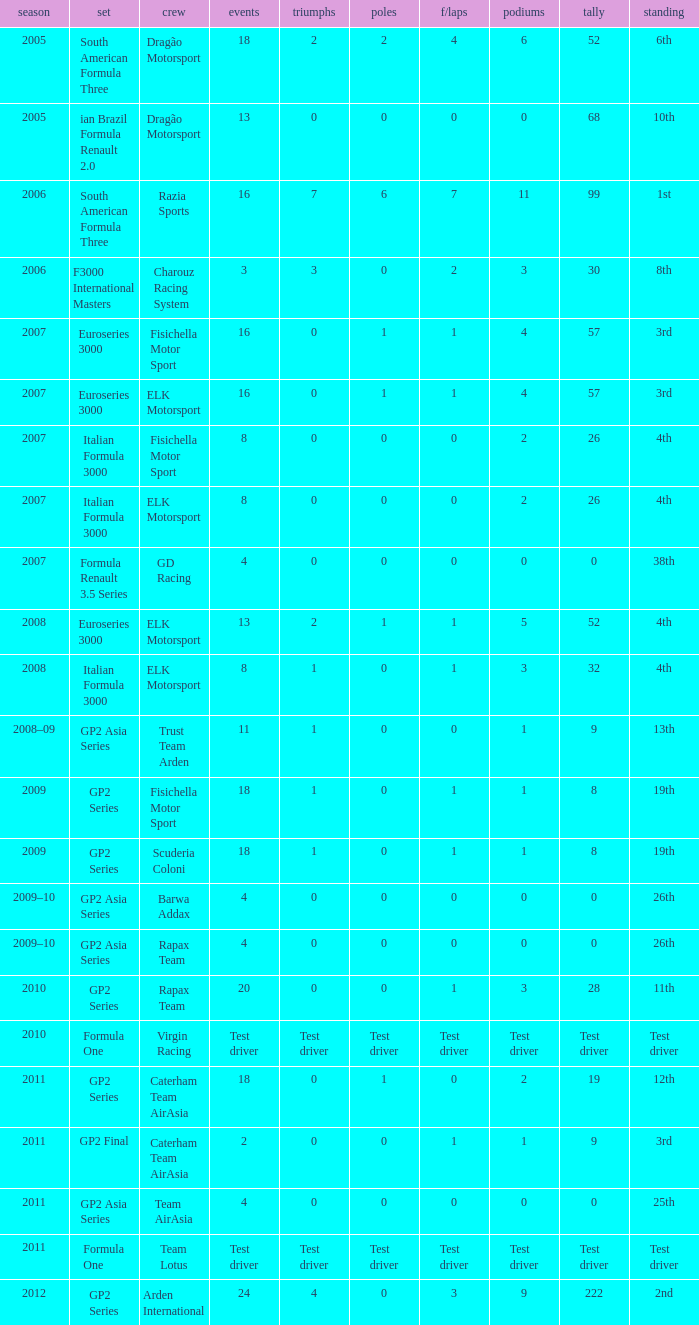In which season did he have 0 Poles and 19th position in the GP2 Series? 2009, 2009. 